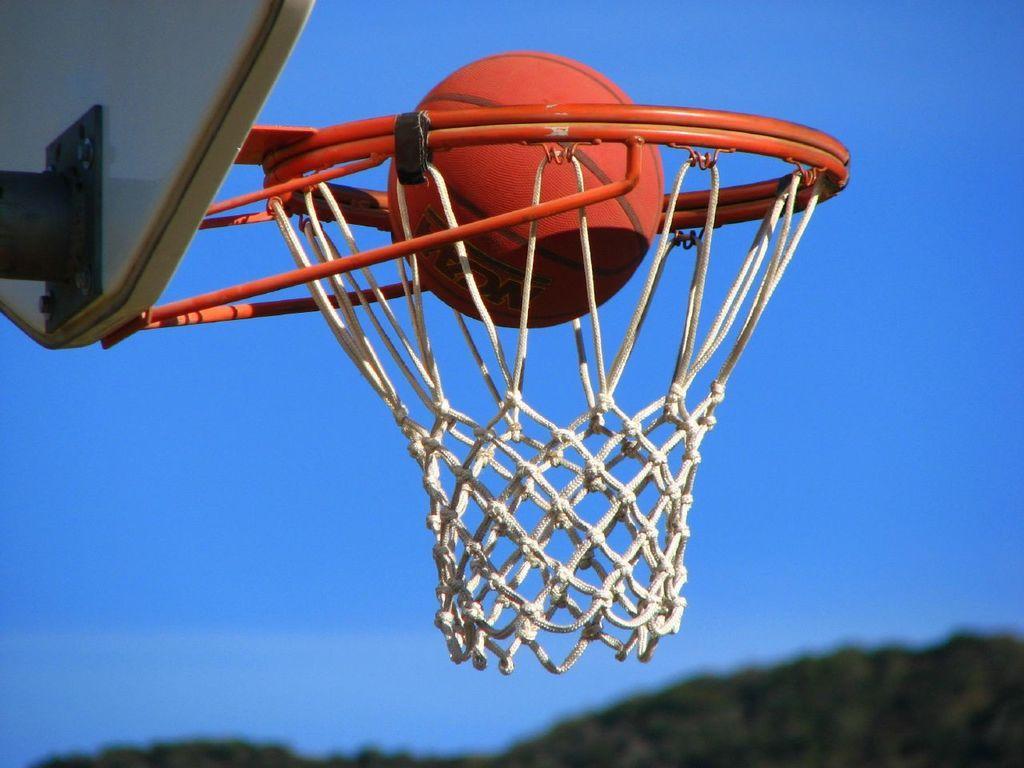In one or two sentences, can you explain what this image depicts? In this image we can see a basketball net,board. There is a basketball. In the background of the image there is sky. At the bottom of the image there are trees. 